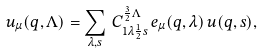<formula> <loc_0><loc_0><loc_500><loc_500>u _ { \mu } ( { q } , \Lambda ) = \sum _ { \lambda , s } \, C _ { 1 { \lambda } { \frac { 1 } { 2 } } s } ^ { { \frac { 3 } { 2 } } \Lambda } \, e _ { \mu } ( { q } , \lambda ) \, u ( { q } , s ) ,</formula> 